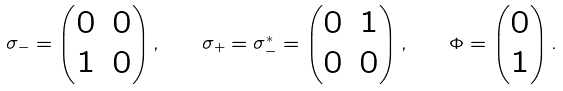Convert formula to latex. <formula><loc_0><loc_0><loc_500><loc_500>\sigma _ { - } = \begin{pmatrix} 0 & 0 \\ 1 & 0 \end{pmatrix} , \quad \sigma _ { + } = \sigma _ { - } ^ { * } = \begin{pmatrix} 0 & 1 \\ 0 & 0 \end{pmatrix} , \quad \Phi = \begin{pmatrix} 0 \\ 1 \end{pmatrix} .</formula> 